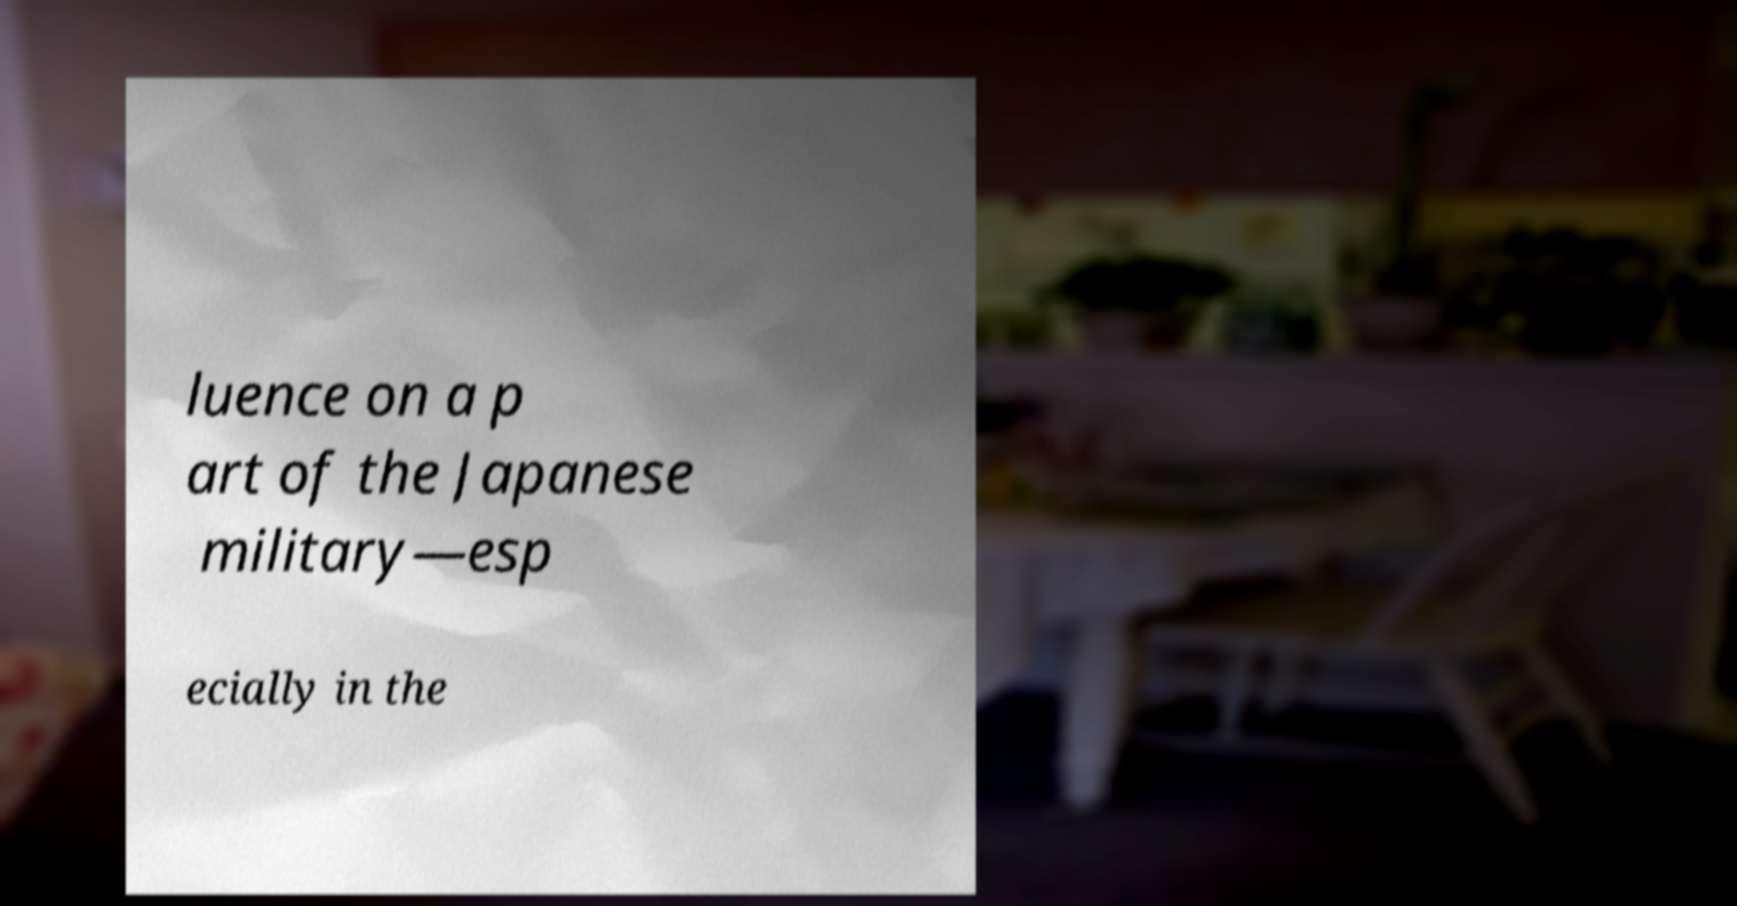Please read and relay the text visible in this image. What does it say? luence on a p art of the Japanese military—esp ecially in the 